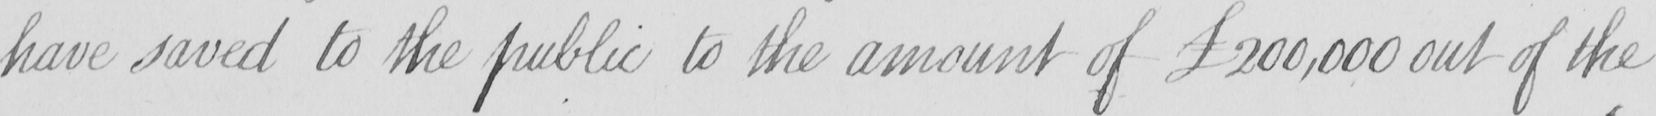What does this handwritten line say? have saved to the public to the amount of £200,000 out of the 